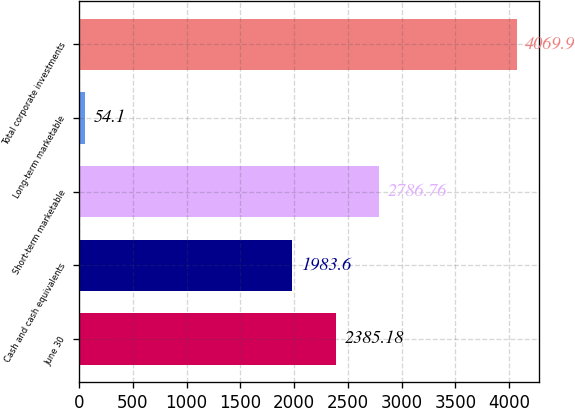Convert chart to OTSL. <chart><loc_0><loc_0><loc_500><loc_500><bar_chart><fcel>June 30<fcel>Cash and cash equivalents<fcel>Short-term marketable<fcel>Long-term marketable<fcel>Total corporate investments<nl><fcel>2385.18<fcel>1983.6<fcel>2786.76<fcel>54.1<fcel>4069.9<nl></chart> 